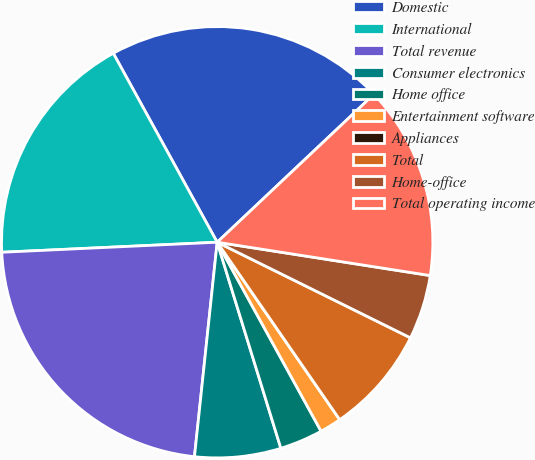Convert chart. <chart><loc_0><loc_0><loc_500><loc_500><pie_chart><fcel>Domestic<fcel>International<fcel>Total revenue<fcel>Consumer electronics<fcel>Home office<fcel>Entertainment software<fcel>Appliances<fcel>Total<fcel>Home-office<fcel>Total operating income<nl><fcel>20.96%<fcel>17.74%<fcel>22.58%<fcel>6.45%<fcel>3.23%<fcel>1.62%<fcel>0.0%<fcel>8.07%<fcel>4.84%<fcel>14.51%<nl></chart> 